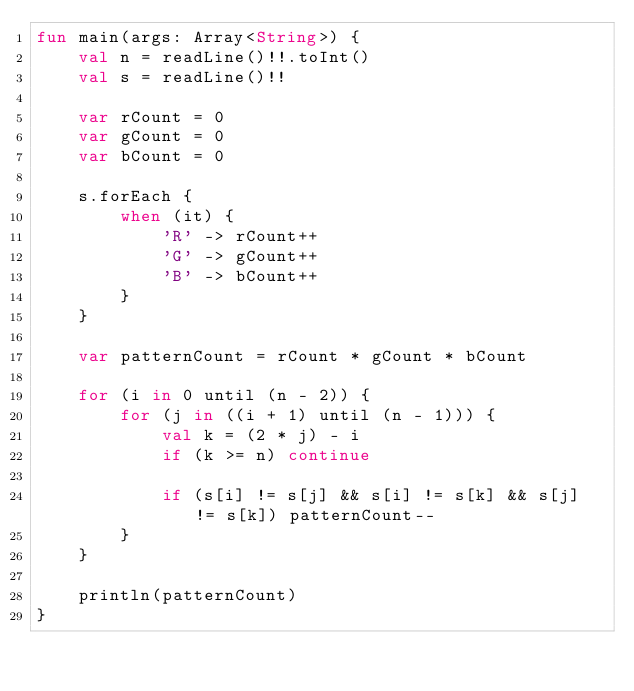<code> <loc_0><loc_0><loc_500><loc_500><_Kotlin_>fun main(args: Array<String>) {
    val n = readLine()!!.toInt()
    val s = readLine()!!

    var rCount = 0
    var gCount = 0
    var bCount = 0

    s.forEach {
        when (it) {
            'R' -> rCount++
            'G' -> gCount++
            'B' -> bCount++
        }
    }

    var patternCount = rCount * gCount * bCount

    for (i in 0 until (n - 2)) {
        for (j in ((i + 1) until (n - 1))) {
            val k = (2 * j) - i
            if (k >= n) continue

            if (s[i] != s[j] && s[i] != s[k] && s[j] != s[k]) patternCount--
        }
    }

    println(patternCount)
}

</code> 